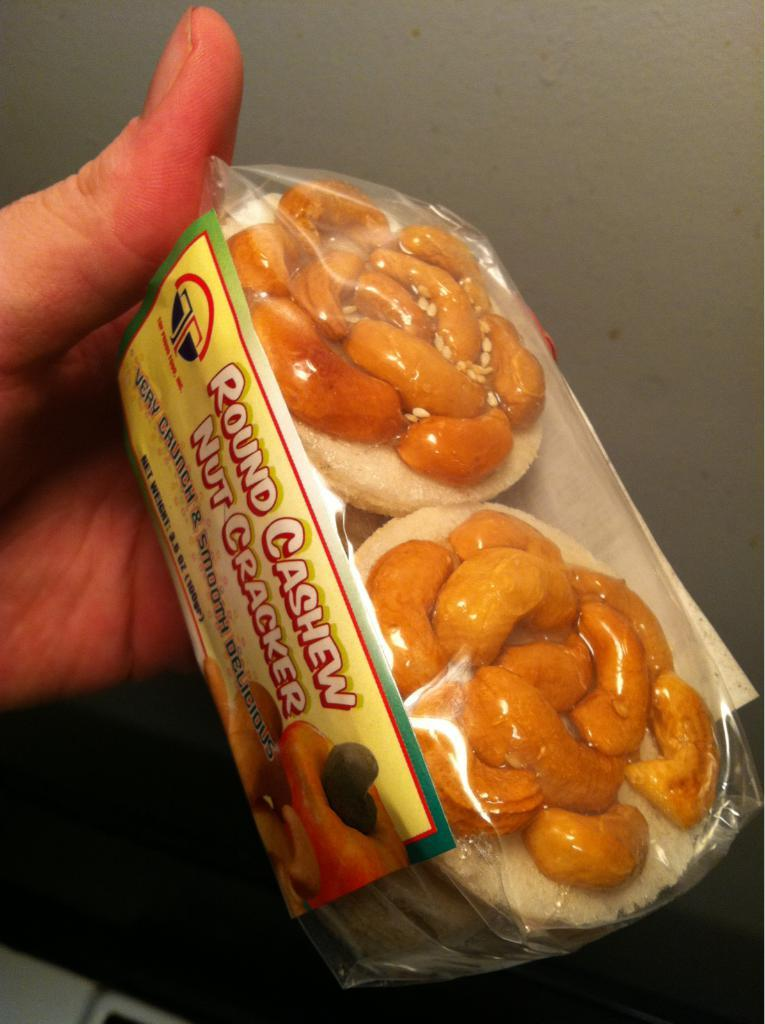What is the person's hand holding in the image? There is a person's hand holding a food item in the image. What structure can be seen at the top of the image? There is a well visible at the top of the image. What type of learning can be observed in the image? There is no learning activity depicted in the image; it features a person's hand holding a food item and a well in the background. How many bulbs are present in the image? There are no bulbs present in the image. 